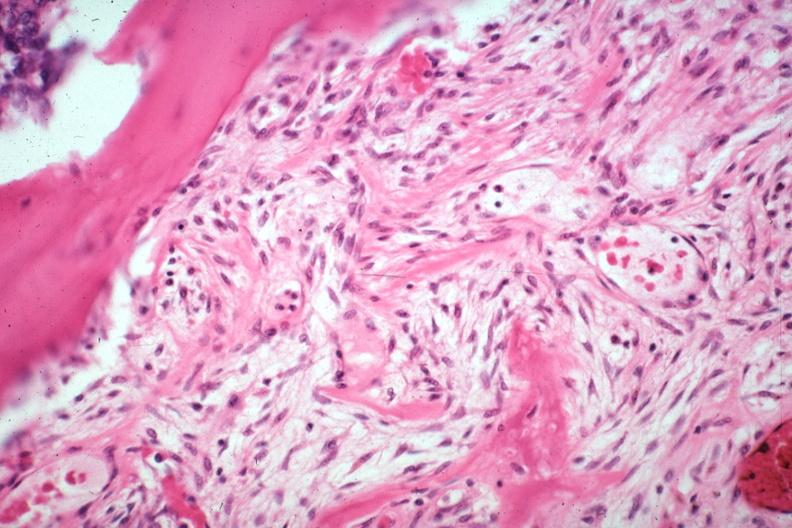what does this image show?
Answer the question using a single word or phrase. Tumor induced new bone formation large myofibroblastic osteoblastic cells in stroma with focus of osteoid case of 8 year survival breast intraductal papillary adenocarcinoma 